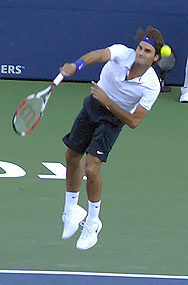Identify and read out the text in this image. ERS 